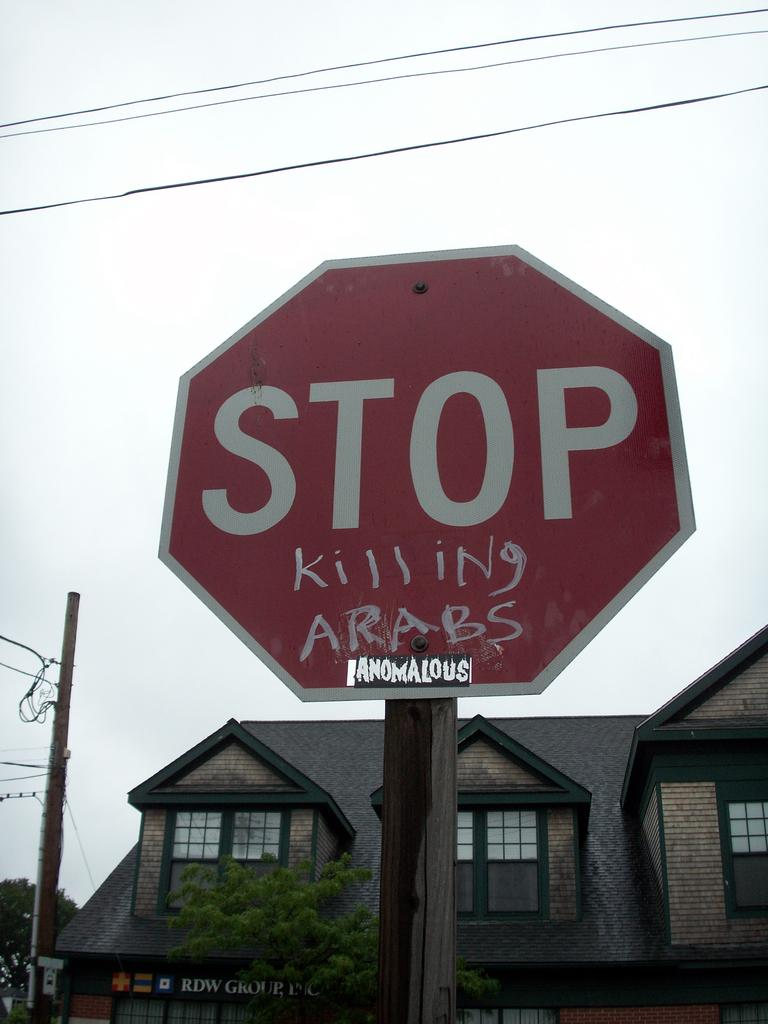<image>
Share a concise interpretation of the image provided. A stop sign that has Killing Arabs written on it. 